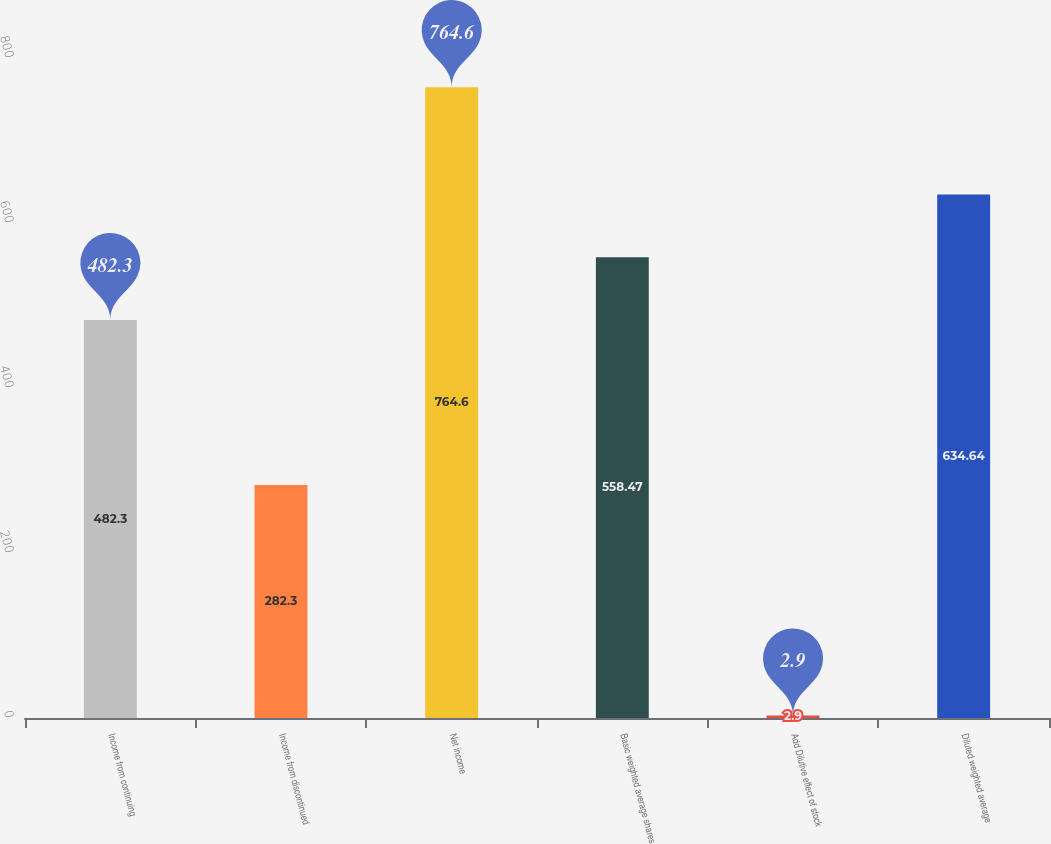Convert chart. <chart><loc_0><loc_0><loc_500><loc_500><bar_chart><fcel>Income from continuing<fcel>Income from discontinued<fcel>Net income<fcel>Basic weighted average shares<fcel>Add Dilutive effect of stock<fcel>Diluted weighted average<nl><fcel>482.3<fcel>282.3<fcel>764.6<fcel>558.47<fcel>2.9<fcel>634.64<nl></chart> 